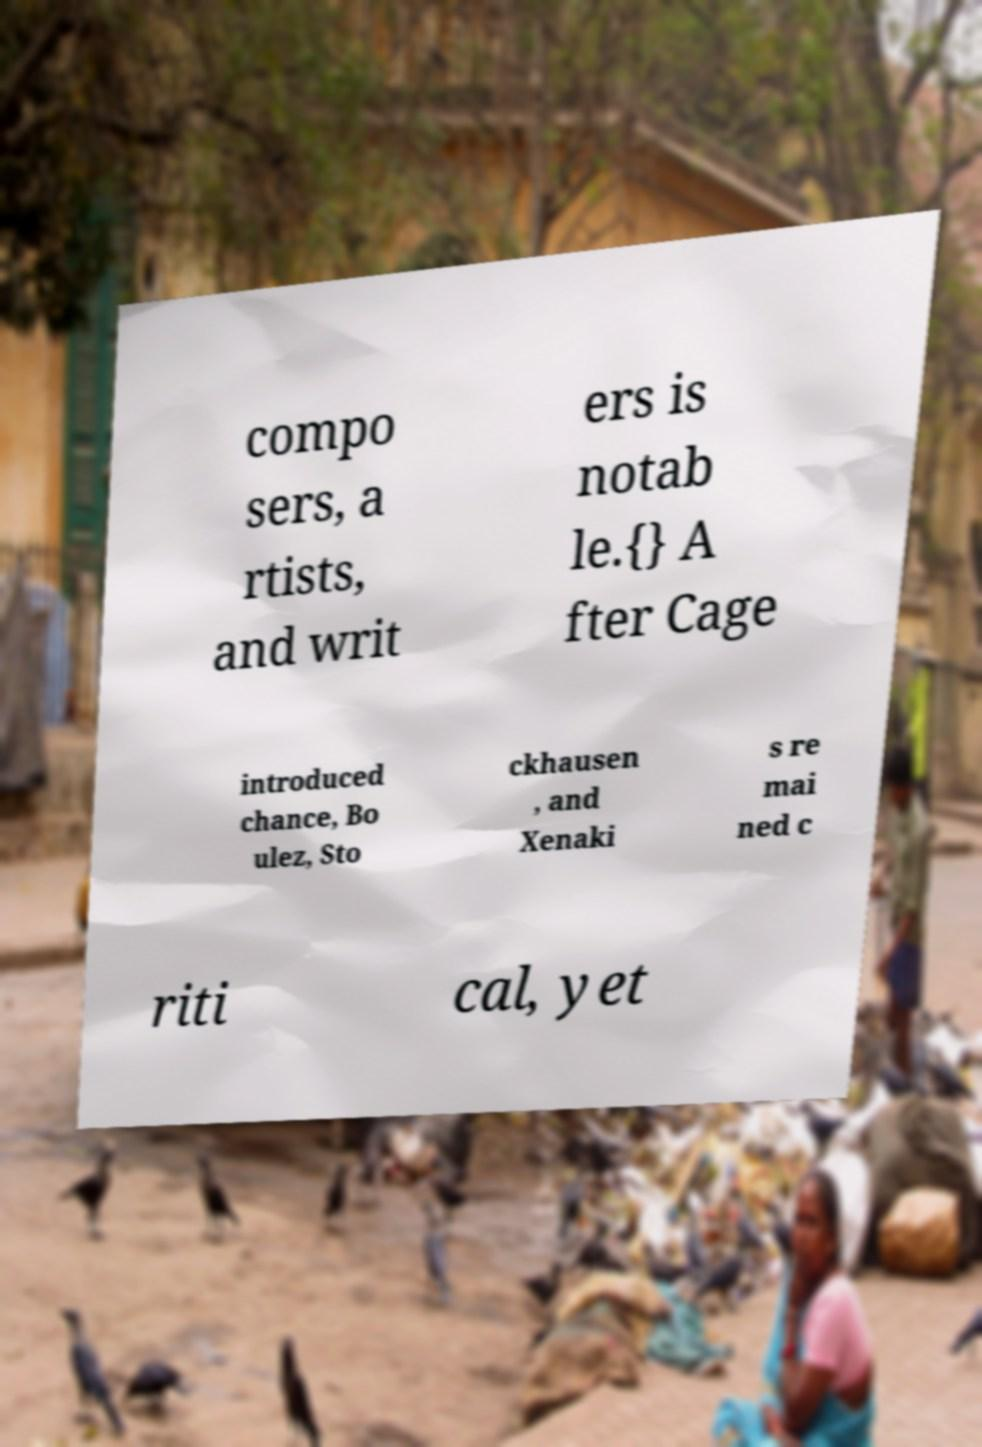For documentation purposes, I need the text within this image transcribed. Could you provide that? compo sers, a rtists, and writ ers is notab le.{} A fter Cage introduced chance, Bo ulez, Sto ckhausen , and Xenaki s re mai ned c riti cal, yet 